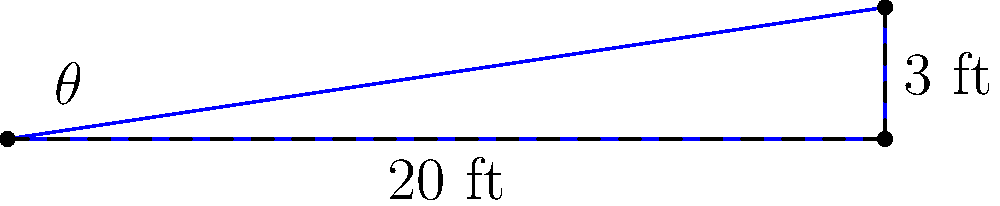As the lead actress in a new production, you've been asked to perform on a raked stage. The stage floor rises 3 feet over a horizontal distance of 20 feet. What is the angle of inclination (θ) of the stage floor to the nearest degree? To find the angle of inclination, we can use the trigonometric function tangent (tan). Here's how:

1. Identify the right triangle formed by the stage:
   - The rise of 3 feet is the opposite side
   - The horizontal distance of 20 feet is the adjacent side
   - The angle we're looking for (θ) is formed between the floor and the incline

2. Use the tangent function:
   $\tan(\theta) = \frac{\text{opposite}}{\text{adjacent}} = \frac{3 \text{ ft}}{20 \text{ ft}} = 0.15$

3. To find θ, we need to use the inverse tangent (arctan or tan^(-1)):
   $\theta = \tan^{-1}(0.15)$

4. Using a calculator or trigonometric tables:
   $\theta ≈ 8.53°$

5. Rounding to the nearest degree:
   $\theta ≈ 9°$

Therefore, the angle of inclination of the stage floor is approximately 9 degrees.
Answer: 9° 